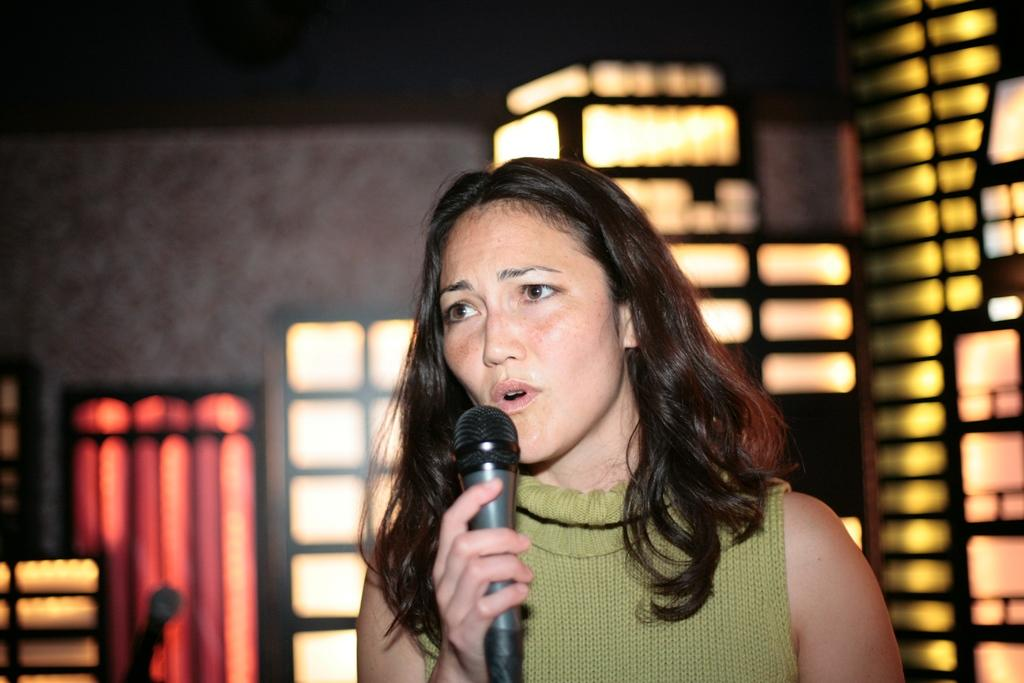What is the main subject of the image? There is a person in the image. What is the person holding in the image? The person is holding a microphone. What can be seen in the background of the image? There is a wall in the background of the image. What color are the person's toenails in the image? There is no information about the person's toenails in the image, so we cannot determine their color. 